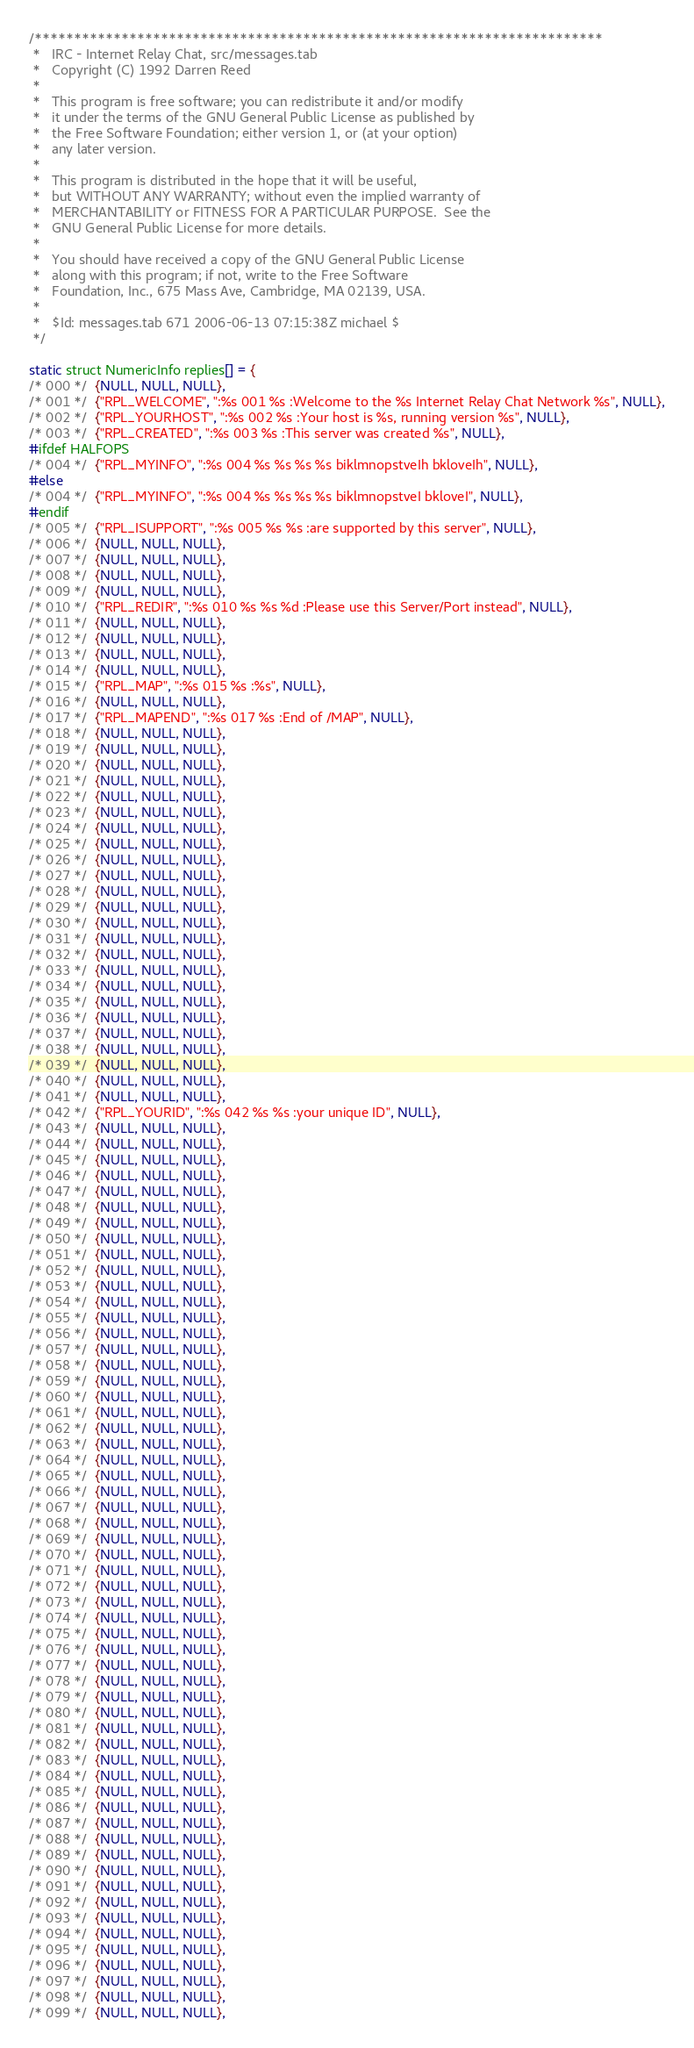Convert code to text. <code><loc_0><loc_0><loc_500><loc_500><_SQL_>/************************************************************************
 *   IRC - Internet Relay Chat, src/messages.tab
 *   Copyright (C) 1992 Darren Reed
 *
 *   This program is free software; you can redistribute it and/or modify
 *   it under the terms of the GNU General Public License as published by
 *   the Free Software Foundation; either version 1, or (at your option)
 *   any later version.
 *
 *   This program is distributed in the hope that it will be useful,
 *   but WITHOUT ANY WARRANTY; without even the implied warranty of
 *   MERCHANTABILITY or FITNESS FOR A PARTICULAR PURPOSE.  See the
 *   GNU General Public License for more details.
 *
 *   You should have received a copy of the GNU General Public License
 *   along with this program; if not, write to the Free Software
 *   Foundation, Inc., 675 Mass Ave, Cambridge, MA 02139, USA.
 *
 *   $Id: messages.tab 671 2006-06-13 07:15:38Z michael $
 */

static struct NumericInfo replies[] = {
/* 000 */  {NULL, NULL, NULL},
/* 001 */  {"RPL_WELCOME", ":%s 001 %s :Welcome to the %s Internet Relay Chat Network %s", NULL},
/* 002 */  {"RPL_YOURHOST", ":%s 002 %s :Your host is %s, running version %s", NULL},
/* 003 */  {"RPL_CREATED", ":%s 003 %s :This server was created %s", NULL},
#ifdef HALFOPS
/* 004 */  {"RPL_MYINFO", ":%s 004 %s %s %s %s biklmnopstveIh bkloveIh", NULL},
#else
/* 004 */  {"RPL_MYINFO", ":%s 004 %s %s %s %s biklmnopstveI bkloveI", NULL},
#endif
/* 005 */  {"RPL_ISUPPORT", ":%s 005 %s %s :are supported by this server", NULL},
/* 006 */  {NULL, NULL, NULL},
/* 007 */  {NULL, NULL, NULL},
/* 008 */  {NULL, NULL, NULL},
/* 009 */  {NULL, NULL, NULL},
/* 010 */  {"RPL_REDIR", ":%s 010 %s %s %d :Please use this Server/Port instead", NULL},
/* 011 */  {NULL, NULL, NULL},
/* 012 */  {NULL, NULL, NULL},
/* 013 */  {NULL, NULL, NULL},
/* 014 */  {NULL, NULL, NULL},
/* 015 */  {"RPL_MAP", ":%s 015 %s :%s", NULL},
/* 016 */  {NULL, NULL, NULL},
/* 017 */  {"RPL_MAPEND", ":%s 017 %s :End of /MAP", NULL},
/* 018 */  {NULL, NULL, NULL},
/* 019 */  {NULL, NULL, NULL},
/* 020 */  {NULL, NULL, NULL},
/* 021 */  {NULL, NULL, NULL},
/* 022 */  {NULL, NULL, NULL},
/* 023 */  {NULL, NULL, NULL},
/* 024 */  {NULL, NULL, NULL},
/* 025 */  {NULL, NULL, NULL},
/* 026 */  {NULL, NULL, NULL},
/* 027 */  {NULL, NULL, NULL},
/* 028 */  {NULL, NULL, NULL},
/* 029 */  {NULL, NULL, NULL},
/* 030 */  {NULL, NULL, NULL},
/* 031 */  {NULL, NULL, NULL},
/* 032 */  {NULL, NULL, NULL},
/* 033 */  {NULL, NULL, NULL},
/* 034 */  {NULL, NULL, NULL},
/* 035 */  {NULL, NULL, NULL},
/* 036 */  {NULL, NULL, NULL},
/* 037 */  {NULL, NULL, NULL},
/* 038 */  {NULL, NULL, NULL},
/* 039 */  {NULL, NULL, NULL},
/* 040 */  {NULL, NULL, NULL},
/* 041 */  {NULL, NULL, NULL},
/* 042 */  {"RPL_YOURID", ":%s 042 %s %s :your unique ID", NULL},
/* 043 */  {NULL, NULL, NULL},
/* 044 */  {NULL, NULL, NULL},
/* 045 */  {NULL, NULL, NULL},
/* 046 */  {NULL, NULL, NULL},
/* 047 */  {NULL, NULL, NULL},
/* 048 */  {NULL, NULL, NULL},
/* 049 */  {NULL, NULL, NULL},
/* 050 */  {NULL, NULL, NULL},
/* 051 */  {NULL, NULL, NULL},
/* 052 */  {NULL, NULL, NULL},
/* 053 */  {NULL, NULL, NULL},
/* 054 */  {NULL, NULL, NULL},
/* 055 */  {NULL, NULL, NULL},
/* 056 */  {NULL, NULL, NULL},
/* 057 */  {NULL, NULL, NULL},
/* 058 */  {NULL, NULL, NULL},
/* 059 */  {NULL, NULL, NULL},
/* 060 */  {NULL, NULL, NULL},
/* 061 */  {NULL, NULL, NULL},
/* 062 */  {NULL, NULL, NULL},
/* 063 */  {NULL, NULL, NULL},
/* 064 */  {NULL, NULL, NULL},
/* 065 */  {NULL, NULL, NULL},
/* 066 */  {NULL, NULL, NULL},
/* 067 */  {NULL, NULL, NULL},
/* 068 */  {NULL, NULL, NULL},
/* 069 */  {NULL, NULL, NULL},
/* 070 */  {NULL, NULL, NULL},
/* 071 */  {NULL, NULL, NULL},
/* 072 */  {NULL, NULL, NULL},
/* 073 */  {NULL, NULL, NULL},
/* 074 */  {NULL, NULL, NULL},
/* 075 */  {NULL, NULL, NULL},
/* 076 */  {NULL, NULL, NULL},
/* 077 */  {NULL, NULL, NULL},
/* 078 */  {NULL, NULL, NULL},
/* 079 */  {NULL, NULL, NULL},
/* 080 */  {NULL, NULL, NULL},
/* 081 */  {NULL, NULL, NULL},
/* 082 */  {NULL, NULL, NULL},
/* 083 */  {NULL, NULL, NULL},
/* 084 */  {NULL, NULL, NULL},
/* 085 */  {NULL, NULL, NULL},
/* 086 */  {NULL, NULL, NULL},
/* 087 */  {NULL, NULL, NULL},
/* 088 */  {NULL, NULL, NULL},
/* 089 */  {NULL, NULL, NULL},
/* 090 */  {NULL, NULL, NULL},
/* 091 */  {NULL, NULL, NULL},
/* 092 */  {NULL, NULL, NULL},
/* 093 */  {NULL, NULL, NULL},
/* 094 */  {NULL, NULL, NULL},
/* 095 */  {NULL, NULL, NULL},
/* 096 */  {NULL, NULL, NULL},
/* 097 */  {NULL, NULL, NULL},
/* 098 */  {NULL, NULL, NULL},
/* 099 */  {NULL, NULL, NULL},</code> 